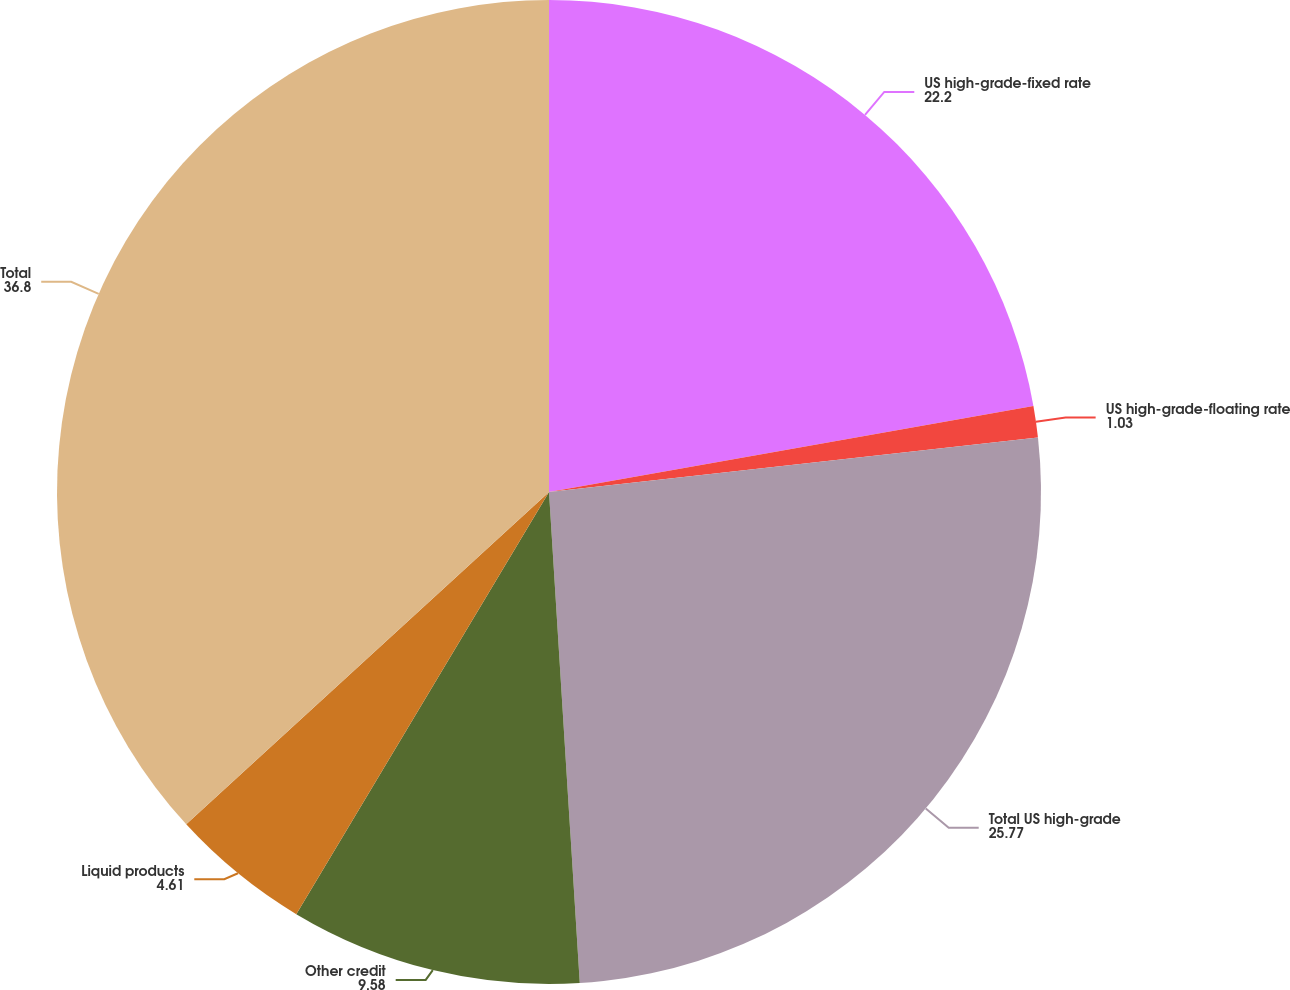<chart> <loc_0><loc_0><loc_500><loc_500><pie_chart><fcel>US high-grade-fixed rate<fcel>US high-grade-floating rate<fcel>Total US high-grade<fcel>Other credit<fcel>Liquid products<fcel>Total<nl><fcel>22.2%<fcel>1.03%<fcel>25.77%<fcel>9.58%<fcel>4.61%<fcel>36.8%<nl></chart> 